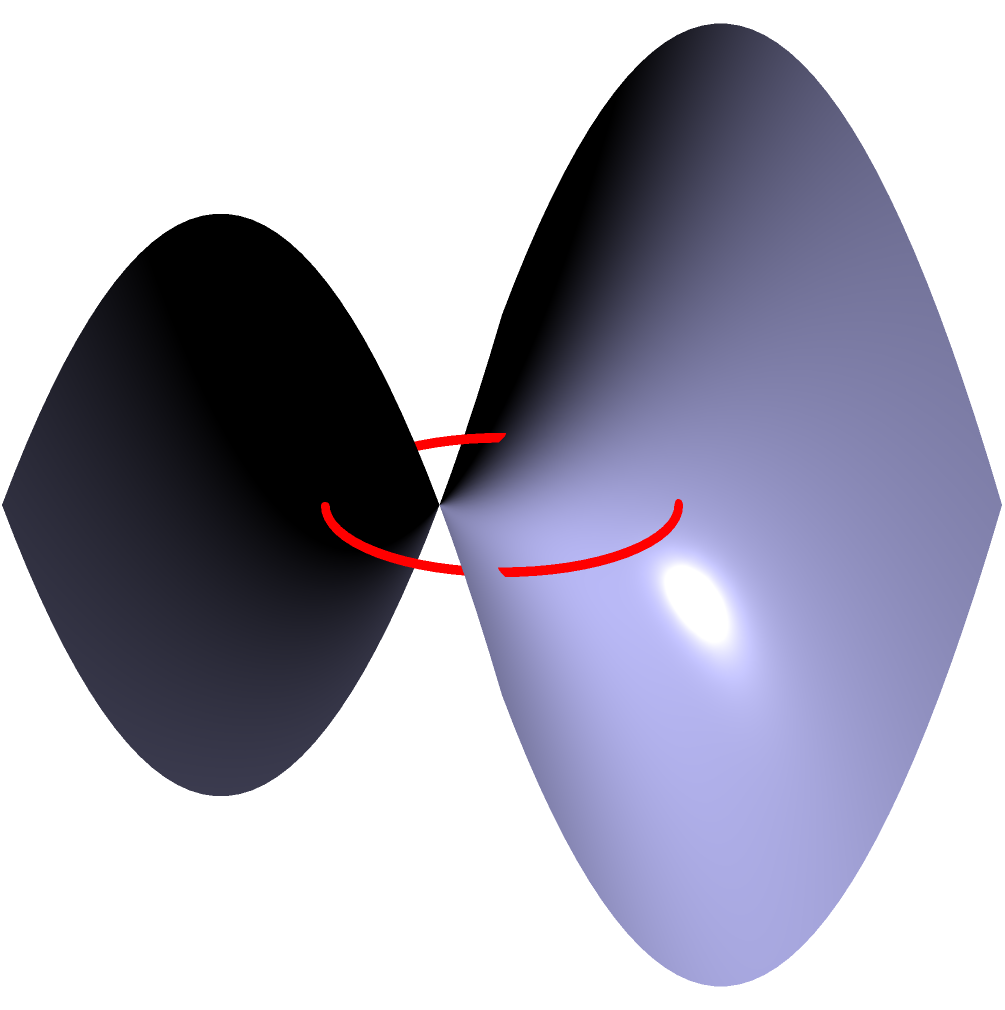As a supplier of high-quality products, you're exploring innovative packaging designs. You come across a saddle-shaped surface described by the equation $z = \frac{1}{2}(x^2 - y^2)$. If you want to place a circular label with radius 1 unit centered at the origin on this surface, what would be the actual area of the label when adhered to the curved surface? To find the area of the circular label on the saddle-shaped surface, we need to follow these steps:

1) The saddle surface is described by $z = \frac{1}{2}(x^2 - y^2)$. This is a hyperbolic paraboloid.

2) To calculate the area on a curved surface, we need to use the formula for surface area in polar coordinates:

   $A = \int_0^{2\pi} \int_0^1 \sqrt{EG-F^2} \, r \, dr \, d\theta$

   where $E$, $F$, and $G$ are the coefficients of the first fundamental form.

3) For our surface:
   $E = 1 + (\frac{\partial z}{\partial x})^2 = 1 + x^2$
   $F = \frac{\partial z}{\partial x} \cdot \frac{\partial z}{\partial y} = -xy$
   $G = 1 + (\frac{\partial z}{\partial y})^2 = 1 + y^2$

4) Substituting into our area formula:

   $A = \int_0^{2\pi} \int_0^1 \sqrt{(1+x^2)(1+y^2)-x^2y^2} \, r \, dr \, d\theta$

5) In polar coordinates, $x = r\cos\theta$ and $y = r\sin\theta$. Substituting:

   $A = \int_0^{2\pi} \int_0^1 \sqrt{1+r^2} \, r \, dr \, d\theta$

6) Solving the inner integral:

   $\int_0^1 \sqrt{1+r^2} \, r \, dr = \frac{1}{3}((1+r^2)^{3/2}-1)|_0^1 = \frac{1}{3}(\sqrt{8}-1)$

7) The outer integral is simply multiplication by $2\pi$:

   $A = 2\pi \cdot \frac{1}{3}(\sqrt{8}-1) = \frac{2\pi}{3}(\sqrt{8}-1)$

Therefore, the area of the circular label when adhered to the saddle-shaped surface is $\frac{2\pi}{3}(\sqrt{8}-1)$ square units.
Answer: $\frac{2\pi}{3}(\sqrt{8}-1)$ square units 